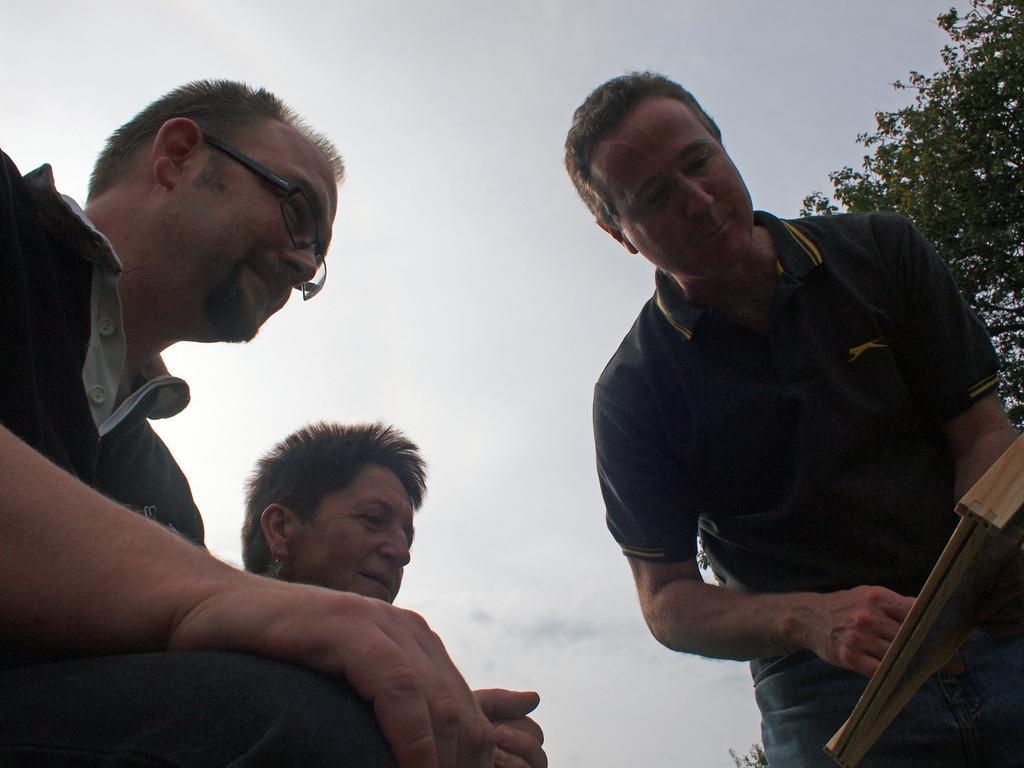How would you summarize this image in a sentence or two? In this image, we can see three persons. There is a person on the right side of the image holding an object with his hand. There is a branch in the top right of the image. There is a sky at the top of the image. 